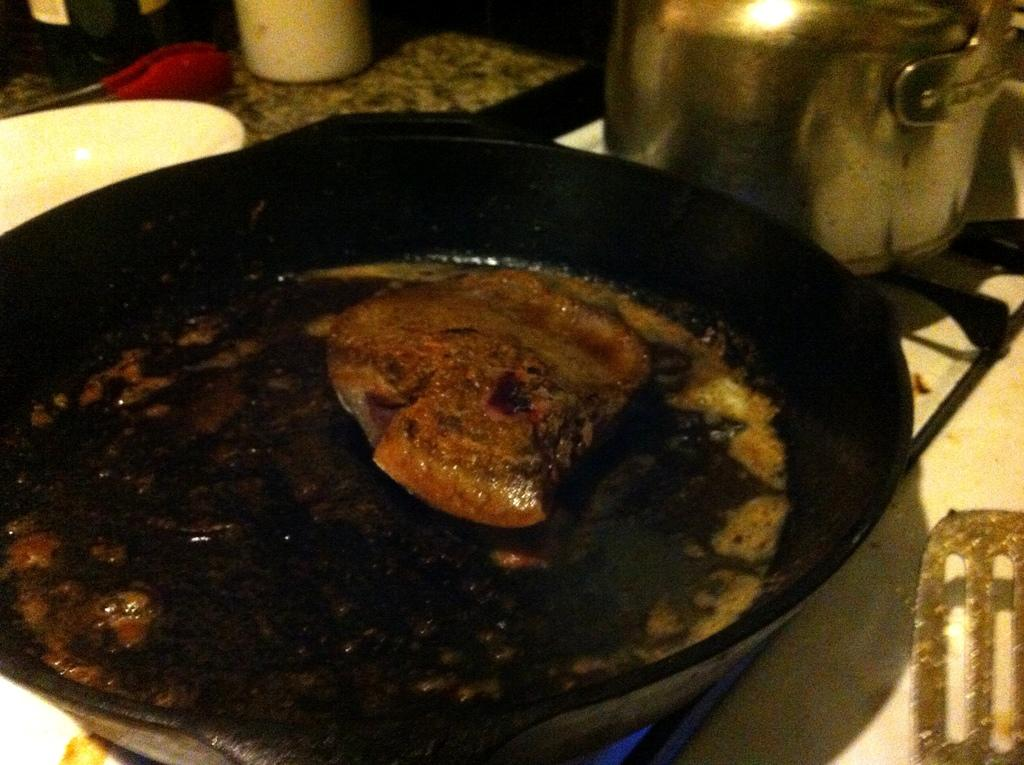What is in the pan that is visible in the image? There is food in a pan in the image. What type of cooking equipment is present in the image? There is a pan and a kettle on a stove in the image. What utensils can be seen in the image? There is a spoon and tongs at the back of the image. What other items are visible at the back of the image? There is a bowl and a bottle at the back of the image. What type of building is visible in the image? There is no building present in the image; it features food in a pan, a pan, a kettle on a stove, a spoon, a bowl, tongs, and a bottle. What type of suit is being worn by the person in the image? There is no person or suit present in the image. How many hands are visible in the image? There are no hands visible in the image. 